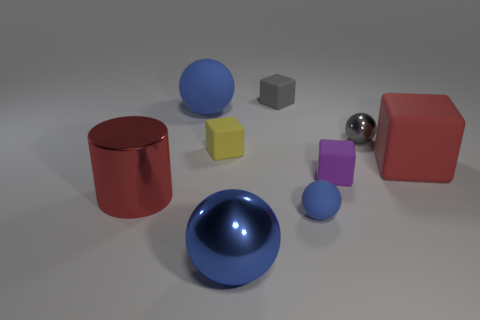What shape is the tiny rubber object that is the same color as the small shiny sphere?
Your answer should be very brief. Cube. Is there another cube that has the same color as the big cube?
Ensure brevity in your answer.  No. How many things are brown metal cylinders or large things in front of the yellow block?
Provide a succinct answer. 3. Are there more yellow matte cubes than tiny matte cubes?
Give a very brief answer. No. What size is the thing that is the same color as the small metallic ball?
Your response must be concise. Small. Is there a cyan thing that has the same material as the gray cube?
Provide a short and direct response. No. There is a object that is both on the right side of the blue shiny thing and in front of the metal cylinder; what is its shape?
Provide a succinct answer. Sphere. What number of other objects are there of the same shape as the big red shiny thing?
Ensure brevity in your answer.  0. What size is the red shiny thing?
Offer a very short reply. Large. What number of objects are small green things or red metal cylinders?
Offer a very short reply. 1. 